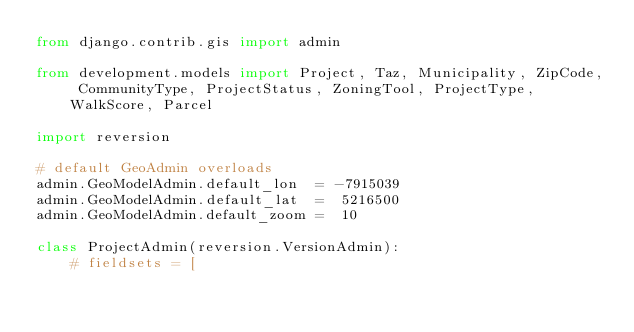<code> <loc_0><loc_0><loc_500><loc_500><_Python_>from django.contrib.gis import admin

from development.models import Project, Taz, Municipality, ZipCode, CommunityType, ProjectStatus, ZoningTool, ProjectType, WalkScore, Parcel

import reversion

# default GeoAdmin overloads
admin.GeoModelAdmin.default_lon  = -7915039
admin.GeoModelAdmin.default_lat  =  5216500 
admin.GeoModelAdmin.default_zoom =  10

class ProjectAdmin(reversion.VersionAdmin):
    # fieldsets = [</code> 